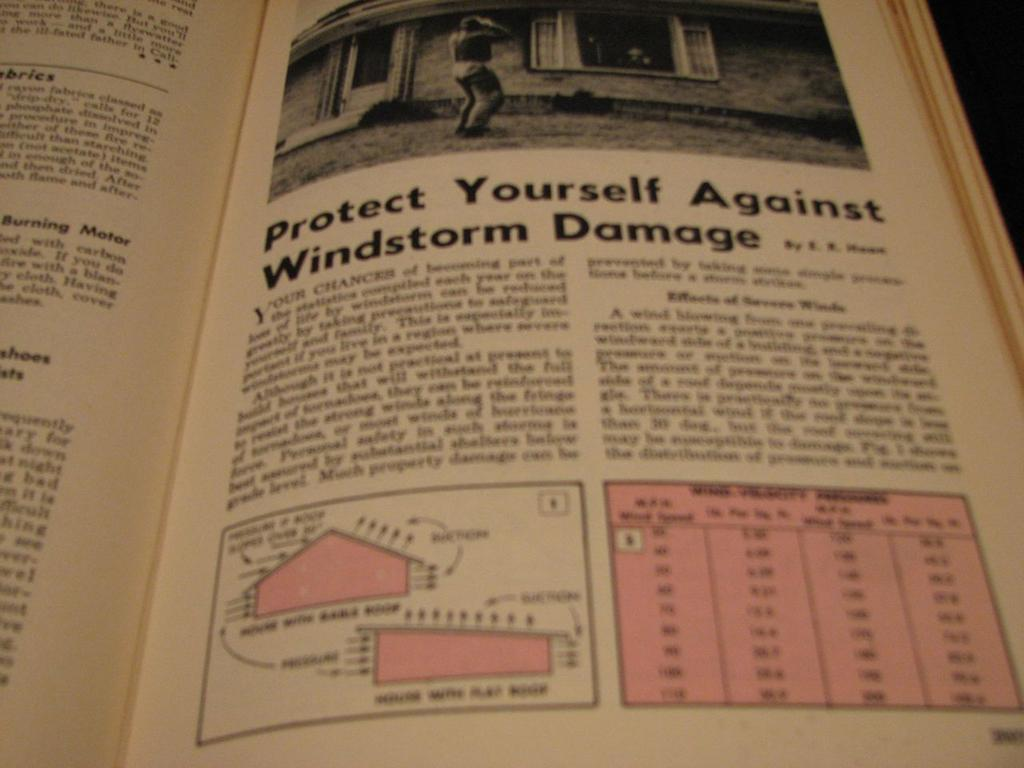Provide a one-sentence caption for the provided image. A book with information regarding protecting yourself against windstorm damage. 